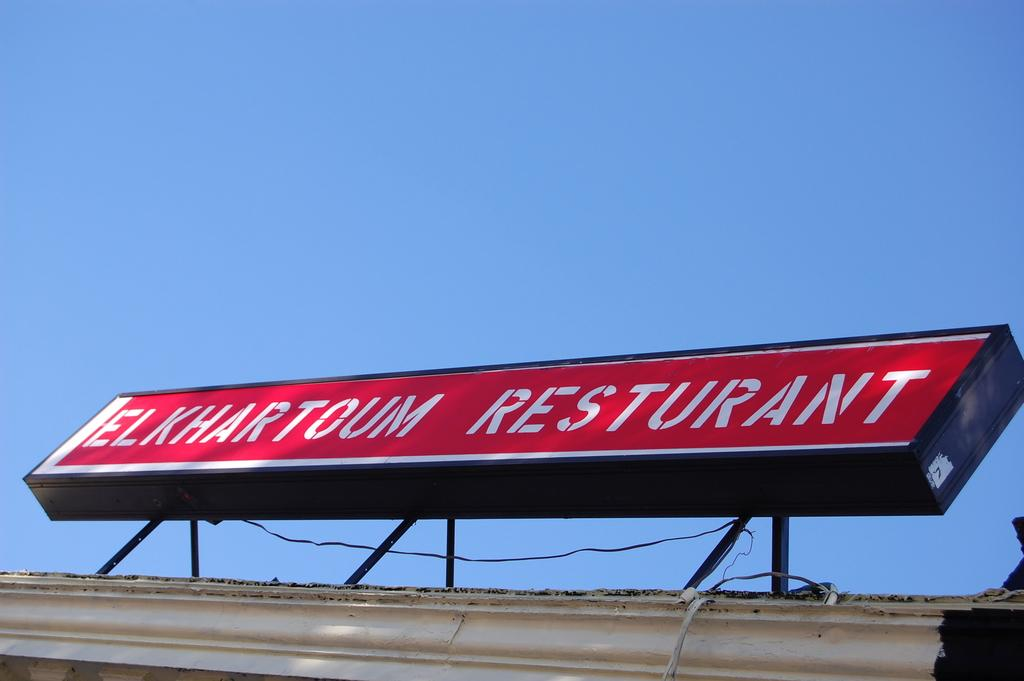<image>
Share a concise interpretation of the image provided. The Elkhartoum restaurant has a nice sign but it is misspelled. 